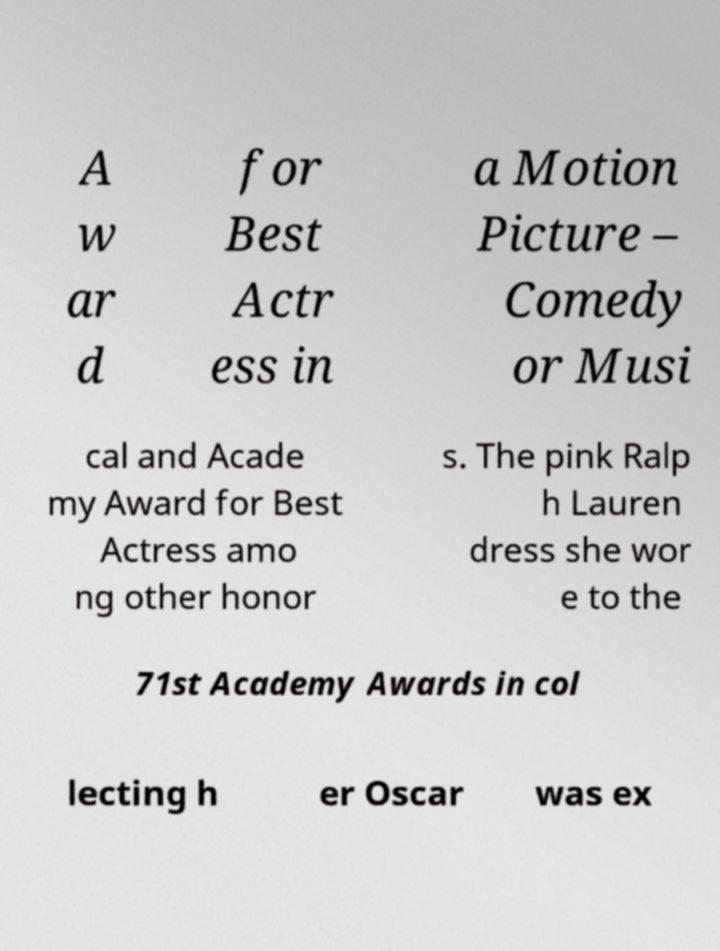Can you accurately transcribe the text from the provided image for me? A w ar d for Best Actr ess in a Motion Picture – Comedy or Musi cal and Acade my Award for Best Actress amo ng other honor s. The pink Ralp h Lauren dress she wor e to the 71st Academy Awards in col lecting h er Oscar was ex 